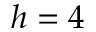Convert formula to latex. <formula><loc_0><loc_0><loc_500><loc_500>h = 4</formula> 